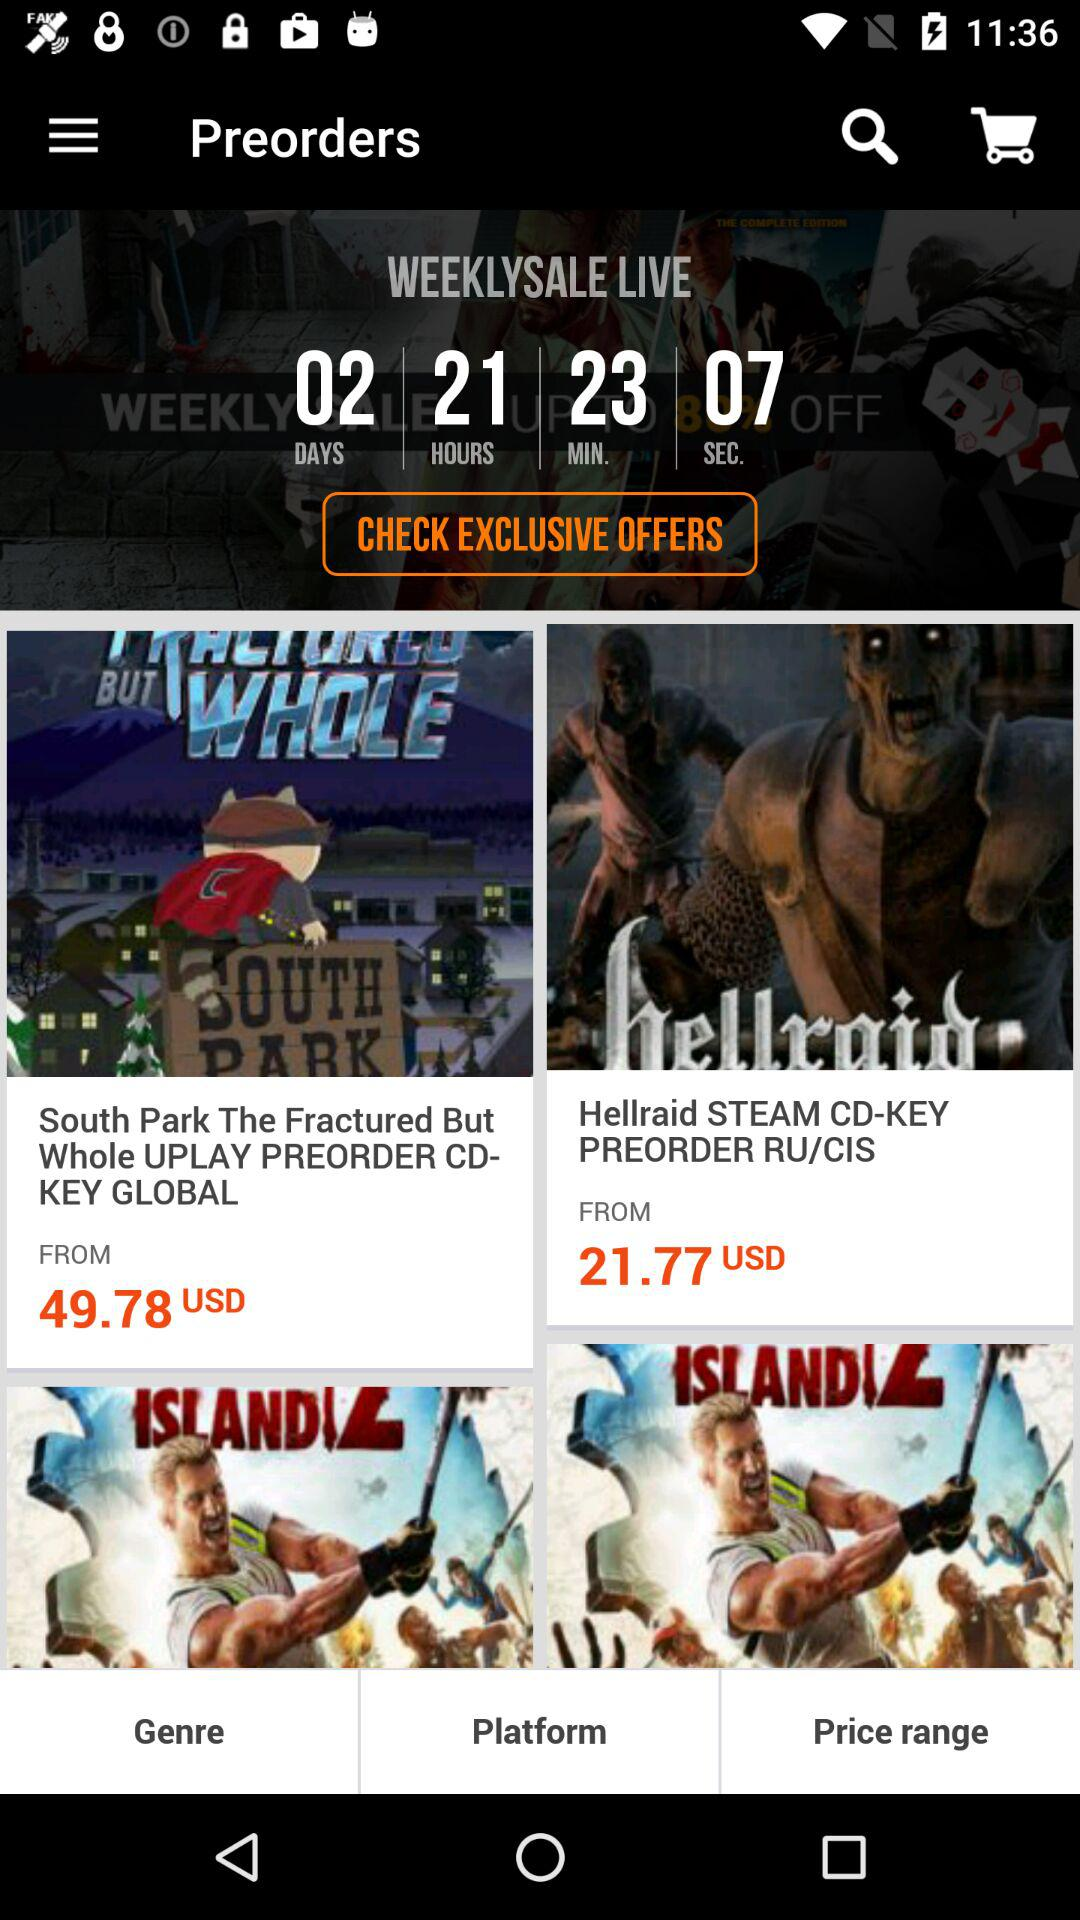What is the price of "Hellraid STEAM" in USD? The price of "Hellraid STEAM CD-KEY" in USD is 21.77. 